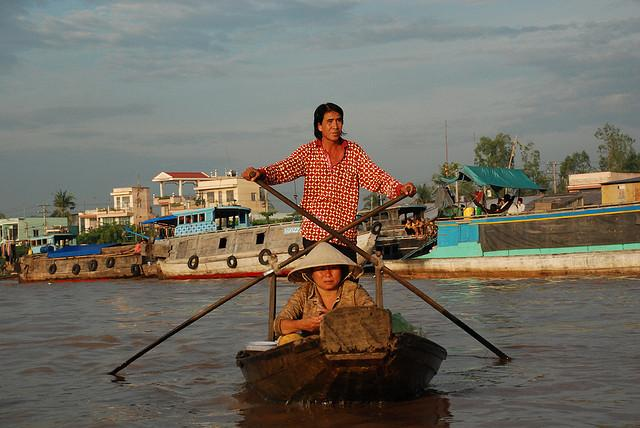The person in the front of the boat is wearing a hat from which continent?

Choices:
A) australia
B) asia
C) antarctica
D) africa asia 